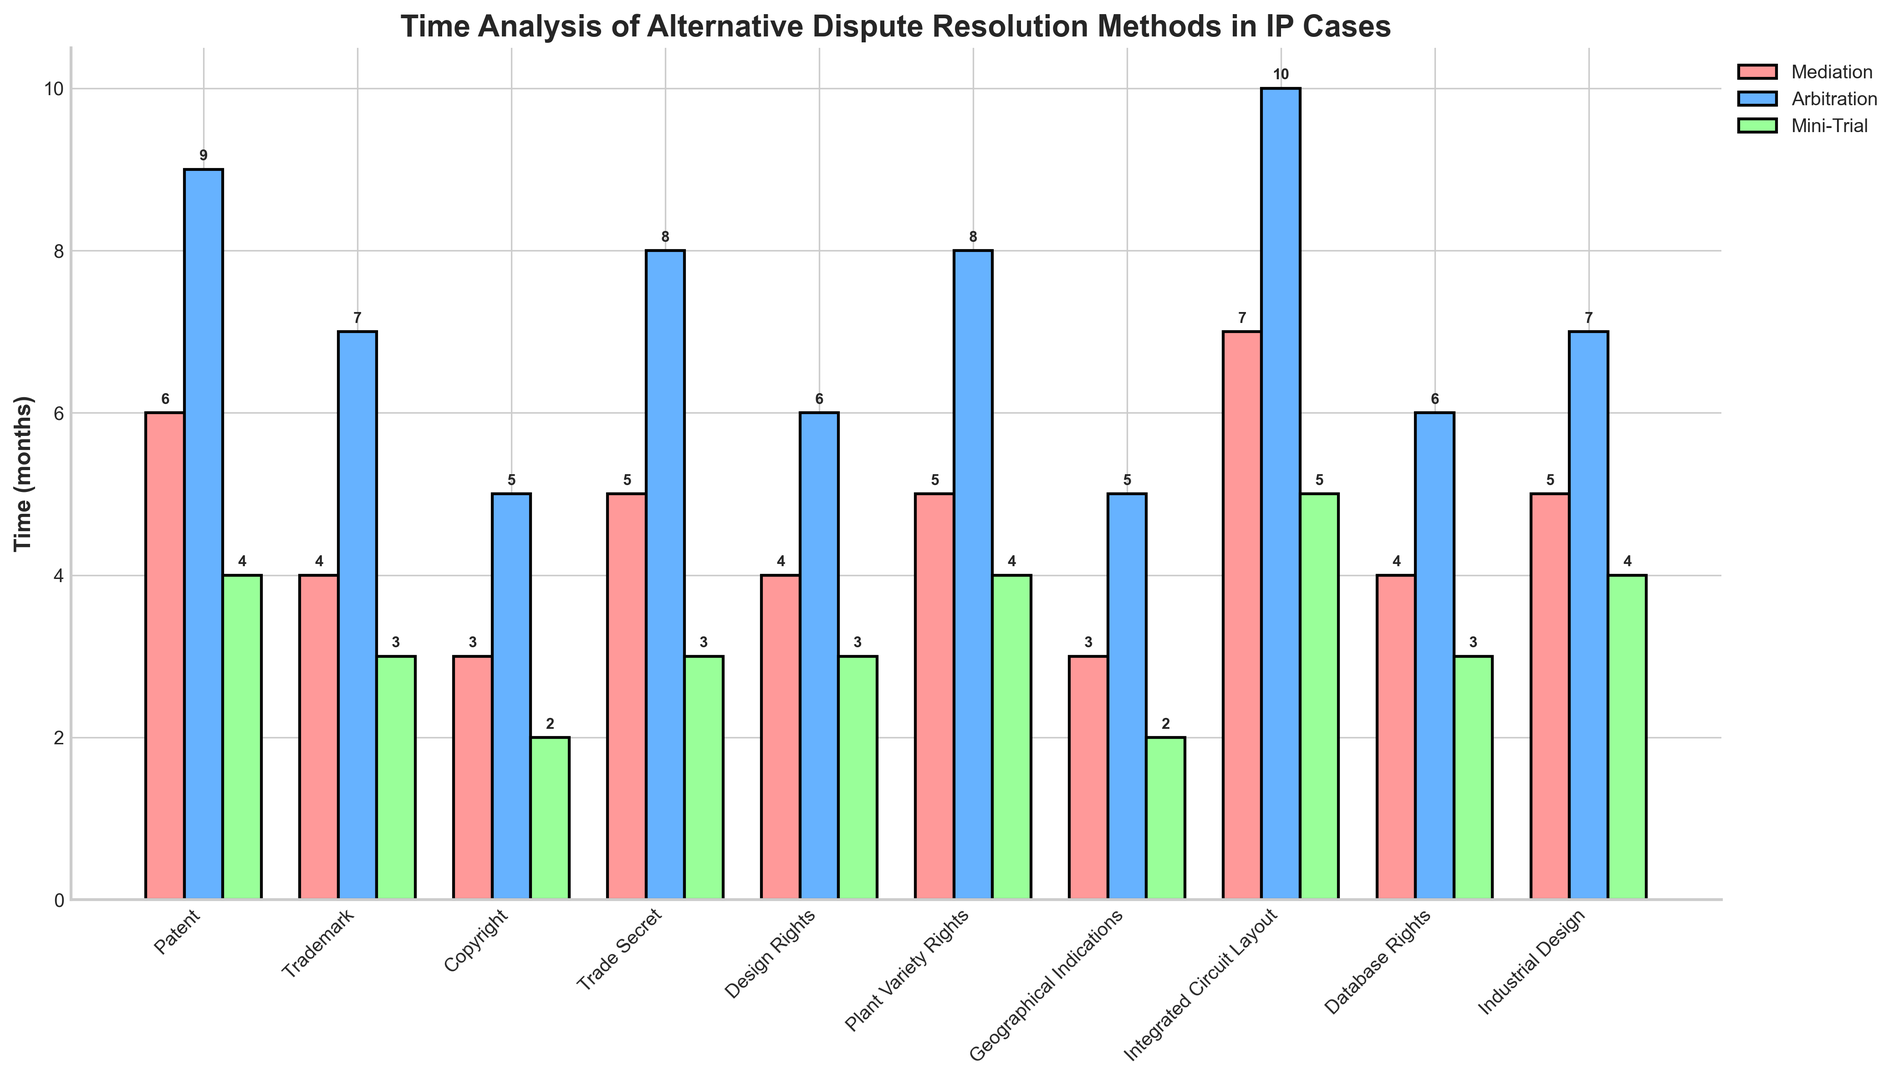What's the total time required for Mediation for all IP types combined? First, list the mediation times for all IP types: 6, 4, 3, 5, 4, 5, 3, 7, 4, 5. Add these values to get the total: 6 + 4 + 3 + 5 + 4 + 5 + 3 + 7 + 4 + 5 = 46 months.
Answer: 46 months Which IP type has the longest time required for Arbitration? Examine the heights of the bars in the "Arbitration" group. The tallest bar corresponds to the Integrated Circuit Layout, which has a time of 10 months.
Answer: Integrated Circuit Layout What is the average time for Mini-Trial across all IP types? List the mini-trial times: 4, 3, 2, 3, 3, 4, 2, 5, 3, 4. Add these values: 4 + 3 + 2 + 3 + 3 + 4 + 2 + 5 + 3 + 4 = 33. Divide by 10 (number of types) to get the average: 33/10 = 3.3 months.
Answer: 3.3 months Which IP types share the same mediation time? Identify bars of equal height within the "Mediation" group. The IP types with heights of 4 are Trademark, Design Rights, and Database Rights. The IP types with heights of 5 are Trade Secret, Plant Variety Rights, and Industrial Design.
Answer: Trademark, Design Rights, Database Rights and Trade Secret, Plant Variety Rights, Industrial Design In which alternative dispute resolution method is the average time required lesser, Mediation or Arbitration? First list the mediation times (6, 4, 3, 5, 4, 5, 3, 7, 4, 5) and arbitration times (9, 7, 5, 8, 6, 8, 5, 10, 6, 7). Calculate the averages: Mediation average = (6 + 4 + 3 + 5 + 4 + 5 + 3 + 7 + 4 + 5) / 10 = 4.6 months; Arbitration average = (9 + 7 + 5 + 8 + 6 + 8 + 5 + 10 + 6 + 7) / 10 = 7.1 months. Mediation has a lower average time.
Answer: Mediation Which IP type has the smallest difference in time between Mediation and Arbitration? Calculate the difference for each IP type: Patent (9-6=3), Trademark (7-4=3), Copyright (5-3=2), Trade Secret (8-5=3), Design Rights (6-4=2), Plant Variety Rights (8-5=3), Geographical Indications (5-3=2), Integrated Circuit Layout (10-7=3), Database Rights (6-4=2), Industrial Design (7-5=2). IP types with the smallest difference (2 months) are Copyright, Design Rights, Geographical Indications, Database Rights, and Industrial Design.
Answer: Copyright, Design Rights, Geographical Indications, Database Rights, Industrial Design What is the average time required for Arbitration for Patent and Trademark cases? First, identify the times for Patent (9) and Trademark (7). Add them: 9 + 7 = 16. Divide by 2 (number of types): 16/2 = 8 months.
Answer: 8 months By how many months does the time required for Mini-Trial exceed that for Mediation in Plant Variety Rights? Subtract the Mediation time from the Mini-Trial time for Plant Variety Rights: 4 - 5 = -1 month. Mini-Trial does not exceed Mediation, it takes 1 month less.
Answer: -1 month 